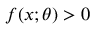Convert formula to latex. <formula><loc_0><loc_0><loc_500><loc_500>f ( x ; \theta ) > 0</formula> 